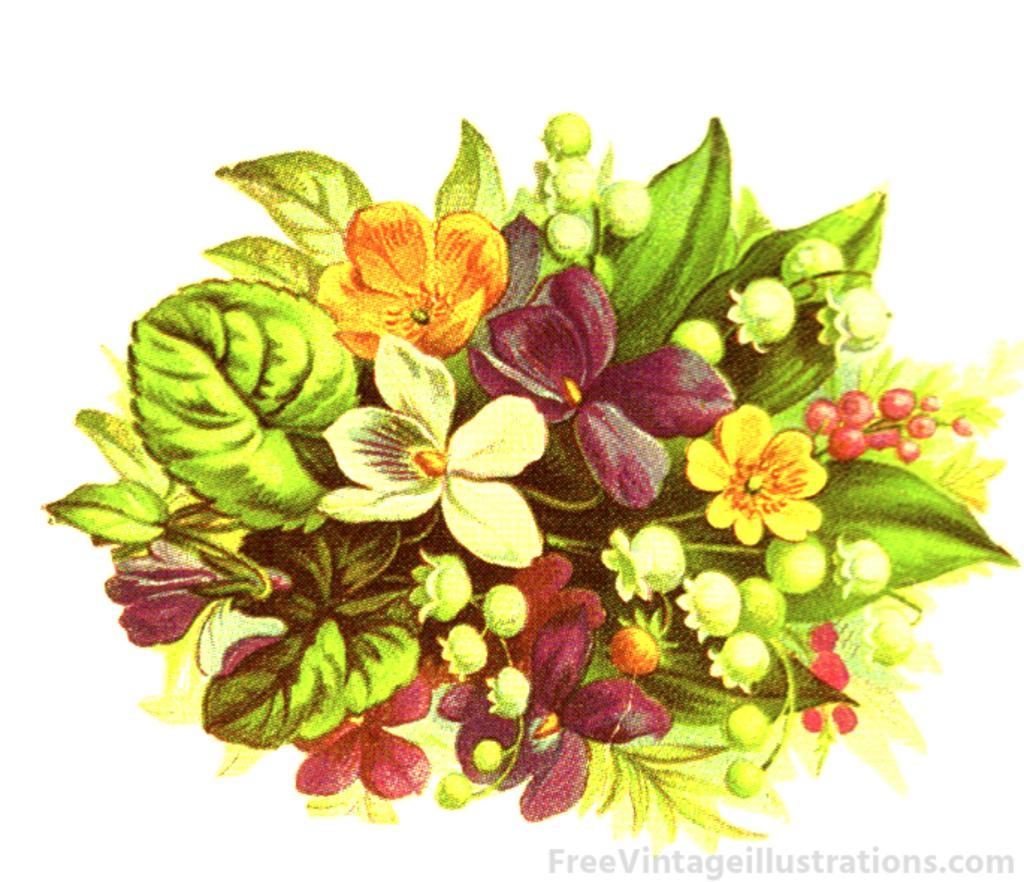How would you summarize this image in a sentence or two? In the image we can see a flower bookey. There are different colors of flowers and there are even leaves. This is a watermark. 